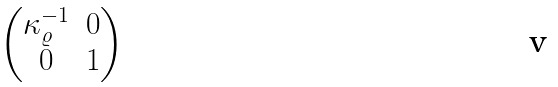<formula> <loc_0><loc_0><loc_500><loc_500>\begin{pmatrix} \kappa _ { \varrho } ^ { - 1 } & 0 \\ 0 & 1 \end{pmatrix}</formula> 